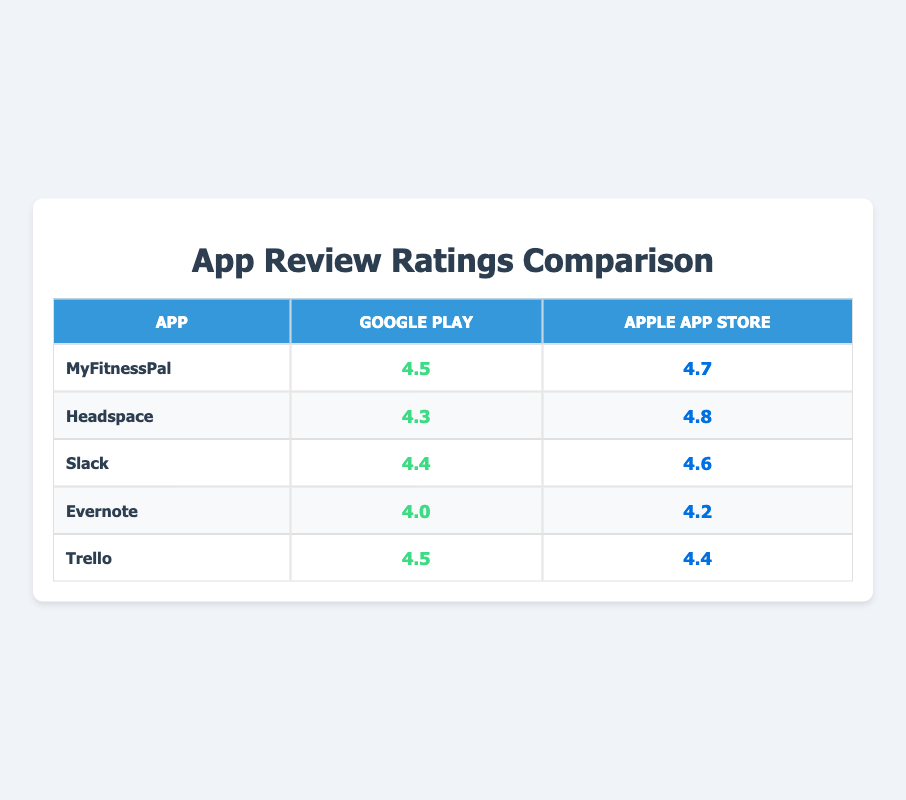What is the rating of MyFitnessPal on the Apple App Store? The table shows that MyFitnessPal has a rating of 4.7 on the Apple App Store. This can be found in the row corresponding to MyFitnessPal and the column for the Apple App Store.
Answer: 4.7 Which app has the highest rating on Google Play? By comparing the ratings in the Google Play column, Headspace has the highest rating of 4.3, while MyFitnessPal has a rating of 4.5, which is higher than both Slack (4.4) and Trello (4.5), but not higher than Headspace.
Answer: Headspace What is the difference in ratings for Slack between Google Play and Apple App Store? The rating for Slack on Google Play is 4.4, and on the Apple App Store, it's 4.6. To find the difference, we subtract the Google Play rating from the Apple App Store rating: 4.6 - 4.4 = 0.2.
Answer: 0.2 Is the rating for Evernote higher on Google Play than on the Apple App Store? The table lists Evernote's rating as 4.0 on Google Play and 4.2 on the Apple App Store. Since 4.0 is less than 4.2, we conclude that the rating for Evernote on Google Play is not higher than on the Apple App Store.
Answer: No Which app has the lowest rating on Google Play? By examining the Google Play column, we see that Evernote has the lowest rating of 4.0 compared to all other apps listed.
Answer: Evernote 